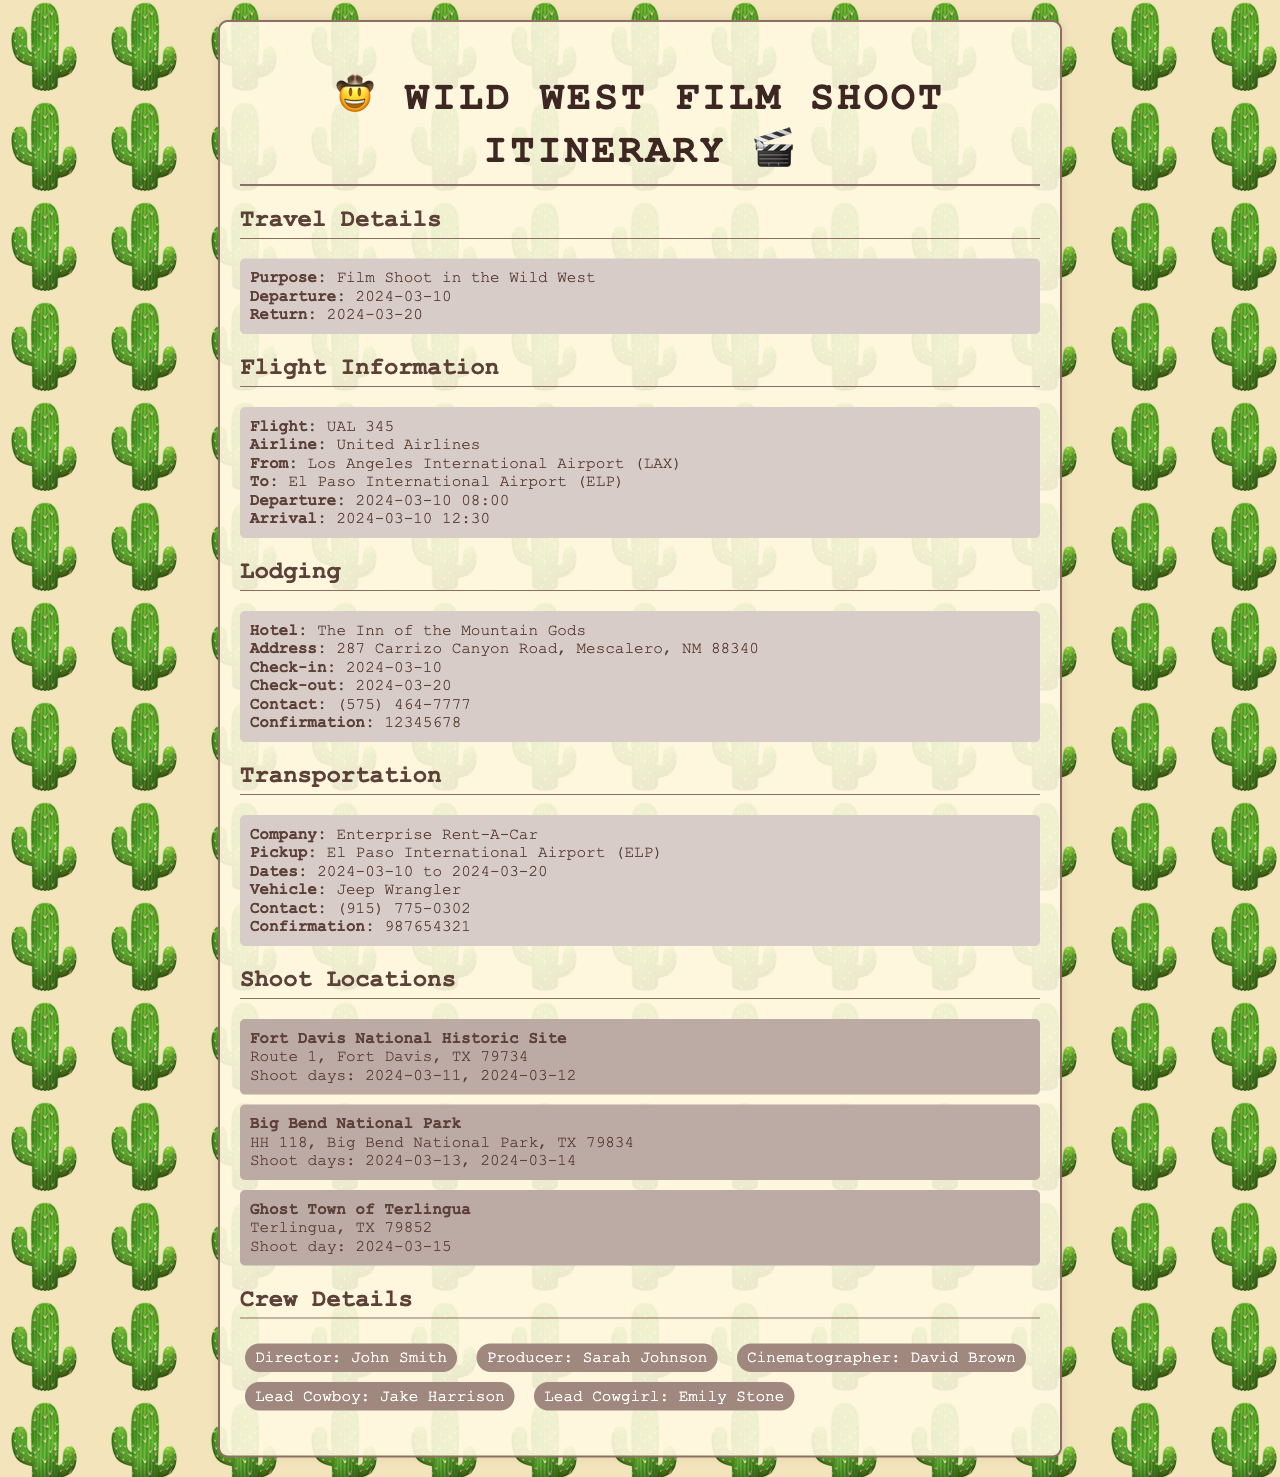What is the flight number? The flight number is explicitly listed under Flight Information in the document.
Answer: UAL 345 What is the check-in date for the hotel? The check-in date is provided in the Lodging section of the document.
Answer: 2024-03-10 What type of vehicle is rented? The vehicle type is mentioned in the Transportation section of the document.
Answer: Jeep Wrangler How many days is the film shoot scheduled for? The departure and return dates indicate the total number of shoot days, which is calculated by counting the days in between.
Answer: 11 days Who is the Lead Cowgirl? The Lead Cowgirl's name appears in the Crew Details section of the document.
Answer: Emily Stone What is the address of the hotel? The hotel's address can be found in the Lodging section.
Answer: 287 Carrizo Canyon Road, Mescalero, NM 88340 When is the shoot at Big Bend National Park? The specific days for the shoot at Big Bend are listed in the Shoot Locations section of the document.
Answer: 2024-03-13, 2024-03-14 What is the contact number for the rental car company? The contact number for Enterprise Rent-A-Car is provided in the Transportation section.
Answer: (915) 775-0302 What date does the film shoot begin? The start of the film shoot is indicated by the Departure date in the Travel Details section.
Answer: 2024-03-10 